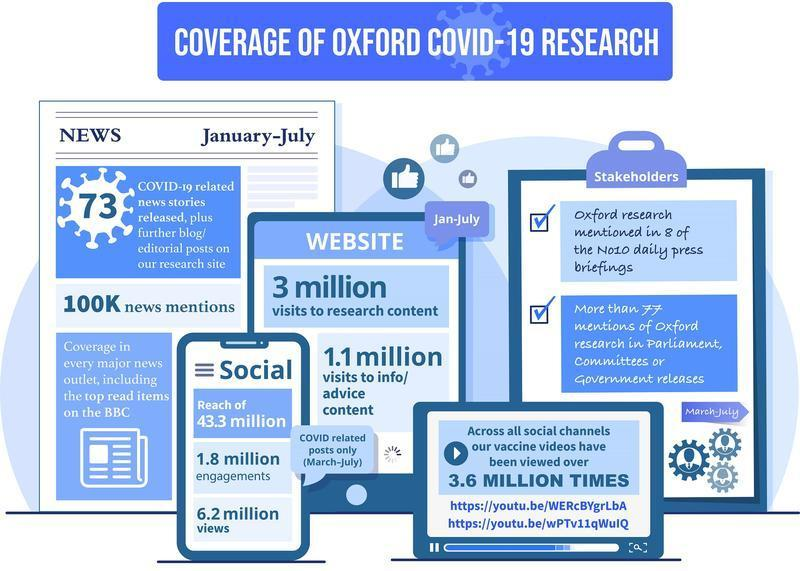How many engagements were caught by Oxford COVID-19 research through social media?
Answer the question with a short phrase. 1.8 million How many people have viewed COVID-19 vaccine videos in social media? 3.6 MILLION How many people searched about Oxford COVID-19 research in the website? 3 million 